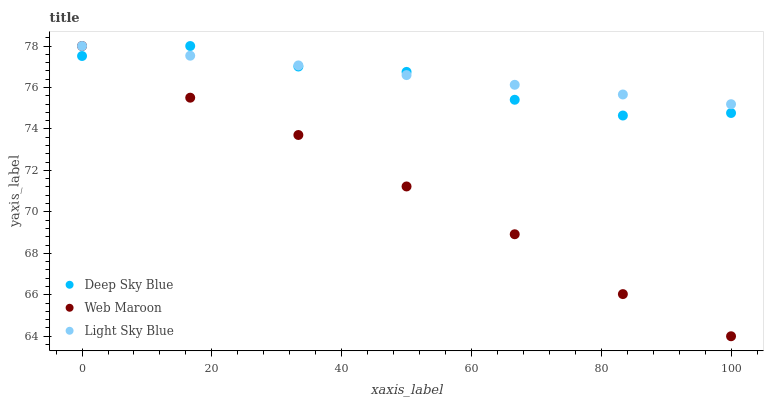Does Web Maroon have the minimum area under the curve?
Answer yes or no. Yes. Does Light Sky Blue have the maximum area under the curve?
Answer yes or no. Yes. Does Deep Sky Blue have the minimum area under the curve?
Answer yes or no. No. Does Deep Sky Blue have the maximum area under the curve?
Answer yes or no. No. Is Light Sky Blue the smoothest?
Answer yes or no. Yes. Is Deep Sky Blue the roughest?
Answer yes or no. Yes. Is Web Maroon the smoothest?
Answer yes or no. No. Is Web Maroon the roughest?
Answer yes or no. No. Does Web Maroon have the lowest value?
Answer yes or no. Yes. Does Deep Sky Blue have the lowest value?
Answer yes or no. No. Does Deep Sky Blue have the highest value?
Answer yes or no. Yes. Does Web Maroon intersect Deep Sky Blue?
Answer yes or no. Yes. Is Web Maroon less than Deep Sky Blue?
Answer yes or no. No. Is Web Maroon greater than Deep Sky Blue?
Answer yes or no. No. 